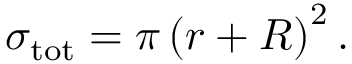Convert formula to latex. <formula><loc_0><loc_0><loc_500><loc_500>\sigma _ { t o t } = \pi \left ( r + R \right ) ^ { 2 } .</formula> 